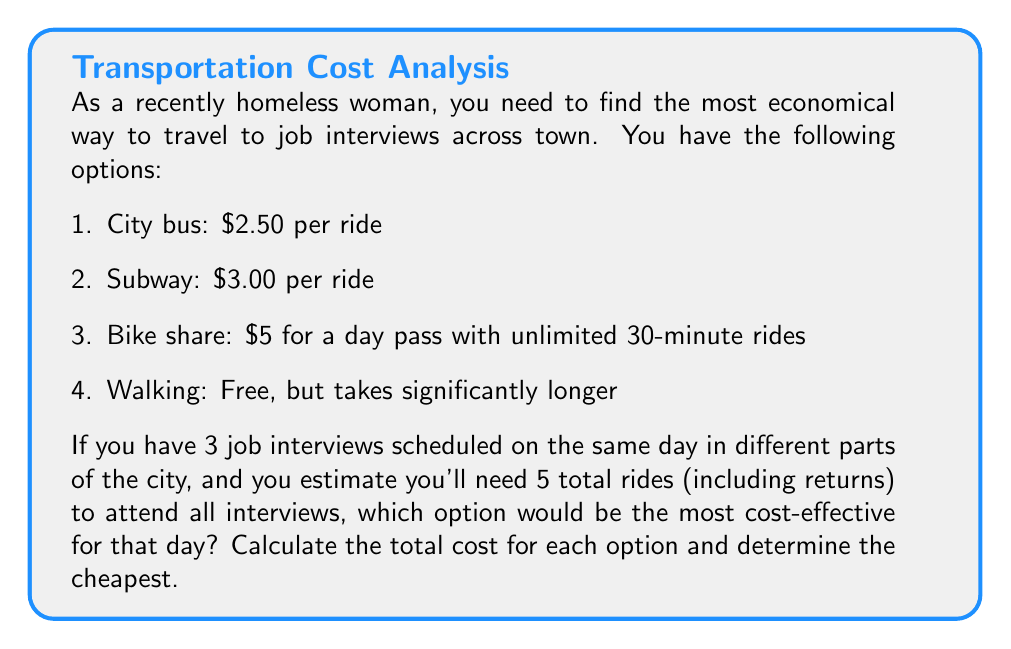Solve this math problem. Let's calculate the cost for each option:

1. City bus:
   $$\text{Cost} = \$2.50 \times 5 \text{ rides} = \$12.50$$

2. Subway:
   $$\text{Cost} = \$3.00 \times 5 \text{ rides} = \$15.00$$

3. Bike share:
   The day pass covers unlimited 30-minute rides for the entire day, so this is a flat rate.
   $$\text{Cost} = \$5.00$$

4. Walking:
   $$\text{Cost} = \$0$$

Comparing the costs:
$$\begin{align*}
\text{Walking} &< \text{Bike share} < \text{City bus} < \text{Subway} \\
\$0 &< \$5.00 < \$12.50 < \$15.00
\end{align*}$$

While walking is free, it may not be practical due to time constraints and distances between interviews. Among the paid options, the bike share day pass is the most economical at $5.00 for the entire day, regardless of the number of rides taken.
Answer: The most cost-effective option for attending the job interviews is the bike share day pass at $5.00. 